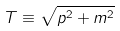Convert formula to latex. <formula><loc_0><loc_0><loc_500><loc_500>T \equiv \sqrt { { p } ^ { 2 } + m ^ { 2 } }</formula> 